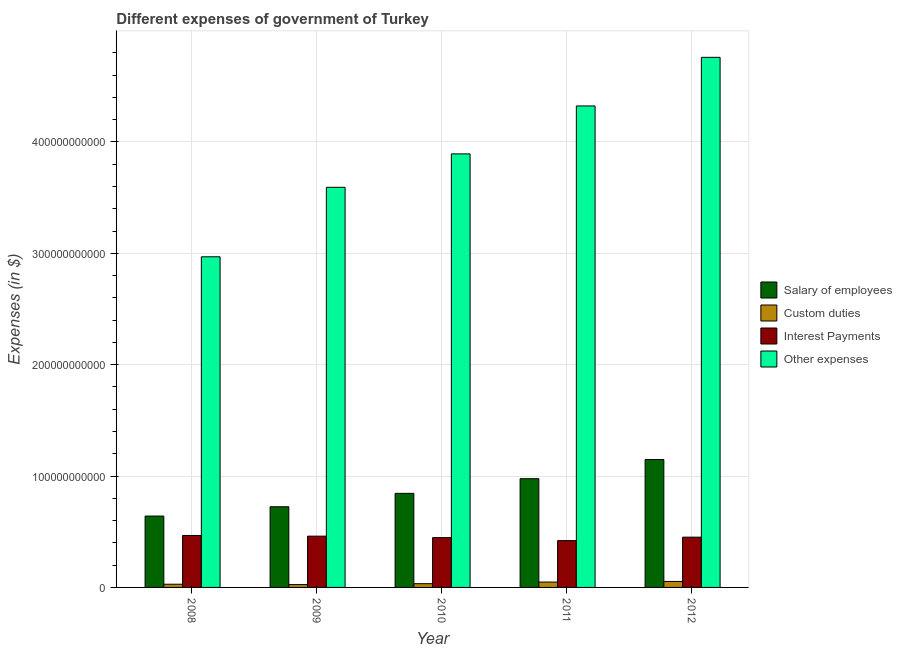How many bars are there on the 5th tick from the right?
Keep it short and to the point. 4. In how many cases, is the number of bars for a given year not equal to the number of legend labels?
Provide a succinct answer. 0. What is the amount spent on other expenses in 2011?
Offer a very short reply. 4.32e+11. Across all years, what is the maximum amount spent on custom duties?
Offer a very short reply. 5.37e+09. Across all years, what is the minimum amount spent on other expenses?
Provide a short and direct response. 2.97e+11. In which year was the amount spent on salary of employees minimum?
Give a very brief answer. 2008. What is the total amount spent on custom duties in the graph?
Give a very brief answer. 1.90e+1. What is the difference between the amount spent on custom duties in 2010 and that in 2012?
Offer a very short reply. -2.01e+09. What is the difference between the amount spent on interest payments in 2009 and the amount spent on salary of employees in 2010?
Offer a terse response. 1.33e+09. What is the average amount spent on interest payments per year?
Provide a succinct answer. 4.49e+1. In how many years, is the amount spent on salary of employees greater than 220000000000 $?
Give a very brief answer. 0. What is the ratio of the amount spent on interest payments in 2011 to that in 2012?
Make the answer very short. 0.93. Is the amount spent on interest payments in 2008 less than that in 2011?
Provide a succinct answer. No. What is the difference between the highest and the second highest amount spent on other expenses?
Ensure brevity in your answer.  4.37e+1. What is the difference between the highest and the lowest amount spent on salary of employees?
Your answer should be very brief. 5.07e+1. In how many years, is the amount spent on custom duties greater than the average amount spent on custom duties taken over all years?
Ensure brevity in your answer.  2. What does the 1st bar from the left in 2012 represents?
Offer a very short reply. Salary of employees. What does the 2nd bar from the right in 2008 represents?
Your response must be concise. Interest Payments. How many bars are there?
Your response must be concise. 20. How many years are there in the graph?
Offer a terse response. 5. What is the difference between two consecutive major ticks on the Y-axis?
Your answer should be very brief. 1.00e+11. Does the graph contain any zero values?
Provide a succinct answer. No. Where does the legend appear in the graph?
Provide a succinct answer. Center right. How many legend labels are there?
Keep it short and to the point. 4. What is the title of the graph?
Keep it short and to the point. Different expenses of government of Turkey. Does "Terrestrial protected areas" appear as one of the legend labels in the graph?
Give a very brief answer. No. What is the label or title of the X-axis?
Provide a succinct answer. Year. What is the label or title of the Y-axis?
Provide a short and direct response. Expenses (in $). What is the Expenses (in $) in Salary of employees in 2008?
Keep it short and to the point. 6.41e+1. What is the Expenses (in $) of Custom duties in 2008?
Make the answer very short. 2.87e+09. What is the Expenses (in $) of Interest Payments in 2008?
Your answer should be compact. 4.67e+1. What is the Expenses (in $) of Other expenses in 2008?
Make the answer very short. 2.97e+11. What is the Expenses (in $) of Salary of employees in 2009?
Your answer should be very brief. 7.24e+1. What is the Expenses (in $) in Custom duties in 2009?
Ensure brevity in your answer.  2.56e+09. What is the Expenses (in $) in Interest Payments in 2009?
Provide a short and direct response. 4.60e+1. What is the Expenses (in $) of Other expenses in 2009?
Offer a very short reply. 3.59e+11. What is the Expenses (in $) of Salary of employees in 2010?
Your answer should be very brief. 8.45e+1. What is the Expenses (in $) in Custom duties in 2010?
Offer a very short reply. 3.36e+09. What is the Expenses (in $) of Interest Payments in 2010?
Provide a short and direct response. 4.47e+1. What is the Expenses (in $) in Other expenses in 2010?
Make the answer very short. 3.89e+11. What is the Expenses (in $) of Salary of employees in 2011?
Keep it short and to the point. 9.76e+1. What is the Expenses (in $) in Custom duties in 2011?
Your answer should be very brief. 4.82e+09. What is the Expenses (in $) of Interest Payments in 2011?
Your answer should be very brief. 4.20e+1. What is the Expenses (in $) in Other expenses in 2011?
Keep it short and to the point. 4.32e+11. What is the Expenses (in $) of Salary of employees in 2012?
Offer a very short reply. 1.15e+11. What is the Expenses (in $) of Custom duties in 2012?
Provide a short and direct response. 5.37e+09. What is the Expenses (in $) in Interest Payments in 2012?
Your response must be concise. 4.51e+1. What is the Expenses (in $) in Other expenses in 2012?
Ensure brevity in your answer.  4.76e+11. Across all years, what is the maximum Expenses (in $) of Salary of employees?
Provide a short and direct response. 1.15e+11. Across all years, what is the maximum Expenses (in $) in Custom duties?
Keep it short and to the point. 5.37e+09. Across all years, what is the maximum Expenses (in $) of Interest Payments?
Keep it short and to the point. 4.67e+1. Across all years, what is the maximum Expenses (in $) of Other expenses?
Give a very brief answer. 4.76e+11. Across all years, what is the minimum Expenses (in $) of Salary of employees?
Offer a terse response. 6.41e+1. Across all years, what is the minimum Expenses (in $) of Custom duties?
Keep it short and to the point. 2.56e+09. Across all years, what is the minimum Expenses (in $) in Interest Payments?
Your answer should be compact. 4.20e+1. Across all years, what is the minimum Expenses (in $) in Other expenses?
Make the answer very short. 2.97e+11. What is the total Expenses (in $) in Salary of employees in the graph?
Your answer should be compact. 4.33e+11. What is the total Expenses (in $) in Custom duties in the graph?
Your answer should be compact. 1.90e+1. What is the total Expenses (in $) in Interest Payments in the graph?
Offer a terse response. 2.25e+11. What is the total Expenses (in $) of Other expenses in the graph?
Offer a very short reply. 1.95e+12. What is the difference between the Expenses (in $) in Salary of employees in 2008 and that in 2009?
Ensure brevity in your answer.  -8.34e+09. What is the difference between the Expenses (in $) in Custom duties in 2008 and that in 2009?
Ensure brevity in your answer.  3.18e+08. What is the difference between the Expenses (in $) in Interest Payments in 2008 and that in 2009?
Your answer should be compact. 6.15e+08. What is the difference between the Expenses (in $) of Other expenses in 2008 and that in 2009?
Your response must be concise. -6.24e+1. What is the difference between the Expenses (in $) in Salary of employees in 2008 and that in 2010?
Make the answer very short. -2.04e+1. What is the difference between the Expenses (in $) of Custom duties in 2008 and that in 2010?
Provide a succinct answer. -4.83e+08. What is the difference between the Expenses (in $) of Interest Payments in 2008 and that in 2010?
Offer a terse response. 1.95e+09. What is the difference between the Expenses (in $) of Other expenses in 2008 and that in 2010?
Provide a short and direct response. -9.24e+1. What is the difference between the Expenses (in $) of Salary of employees in 2008 and that in 2011?
Your answer should be very brief. -3.35e+1. What is the difference between the Expenses (in $) of Custom duties in 2008 and that in 2011?
Keep it short and to the point. -1.95e+09. What is the difference between the Expenses (in $) in Interest Payments in 2008 and that in 2011?
Keep it short and to the point. 4.62e+09. What is the difference between the Expenses (in $) of Other expenses in 2008 and that in 2011?
Make the answer very short. -1.35e+11. What is the difference between the Expenses (in $) in Salary of employees in 2008 and that in 2012?
Ensure brevity in your answer.  -5.07e+1. What is the difference between the Expenses (in $) in Custom duties in 2008 and that in 2012?
Offer a very short reply. -2.49e+09. What is the difference between the Expenses (in $) in Interest Payments in 2008 and that in 2012?
Provide a succinct answer. 1.53e+09. What is the difference between the Expenses (in $) in Other expenses in 2008 and that in 2012?
Provide a short and direct response. -1.79e+11. What is the difference between the Expenses (in $) of Salary of employees in 2009 and that in 2010?
Your answer should be very brief. -1.20e+1. What is the difference between the Expenses (in $) of Custom duties in 2009 and that in 2010?
Give a very brief answer. -8.01e+08. What is the difference between the Expenses (in $) in Interest Payments in 2009 and that in 2010?
Offer a very short reply. 1.33e+09. What is the difference between the Expenses (in $) of Other expenses in 2009 and that in 2010?
Your response must be concise. -3.00e+1. What is the difference between the Expenses (in $) in Salary of employees in 2009 and that in 2011?
Provide a short and direct response. -2.52e+1. What is the difference between the Expenses (in $) in Custom duties in 2009 and that in 2011?
Make the answer very short. -2.27e+09. What is the difference between the Expenses (in $) of Interest Payments in 2009 and that in 2011?
Provide a succinct answer. 4.01e+09. What is the difference between the Expenses (in $) of Other expenses in 2009 and that in 2011?
Your response must be concise. -7.30e+1. What is the difference between the Expenses (in $) of Salary of employees in 2009 and that in 2012?
Offer a very short reply. -4.24e+1. What is the difference between the Expenses (in $) of Custom duties in 2009 and that in 2012?
Ensure brevity in your answer.  -2.81e+09. What is the difference between the Expenses (in $) of Interest Payments in 2009 and that in 2012?
Your response must be concise. 9.15e+08. What is the difference between the Expenses (in $) in Other expenses in 2009 and that in 2012?
Keep it short and to the point. -1.17e+11. What is the difference between the Expenses (in $) in Salary of employees in 2010 and that in 2011?
Give a very brief answer. -1.32e+1. What is the difference between the Expenses (in $) in Custom duties in 2010 and that in 2011?
Offer a very short reply. -1.46e+09. What is the difference between the Expenses (in $) in Interest Payments in 2010 and that in 2011?
Your answer should be very brief. 2.68e+09. What is the difference between the Expenses (in $) in Other expenses in 2010 and that in 2011?
Give a very brief answer. -4.30e+1. What is the difference between the Expenses (in $) of Salary of employees in 2010 and that in 2012?
Give a very brief answer. -3.04e+1. What is the difference between the Expenses (in $) in Custom duties in 2010 and that in 2012?
Ensure brevity in your answer.  -2.01e+09. What is the difference between the Expenses (in $) of Interest Payments in 2010 and that in 2012?
Your answer should be very brief. -4.16e+08. What is the difference between the Expenses (in $) of Other expenses in 2010 and that in 2012?
Make the answer very short. -8.67e+1. What is the difference between the Expenses (in $) of Salary of employees in 2011 and that in 2012?
Ensure brevity in your answer.  -1.72e+1. What is the difference between the Expenses (in $) of Custom duties in 2011 and that in 2012?
Offer a terse response. -5.47e+08. What is the difference between the Expenses (in $) in Interest Payments in 2011 and that in 2012?
Give a very brief answer. -3.09e+09. What is the difference between the Expenses (in $) in Other expenses in 2011 and that in 2012?
Your response must be concise. -4.37e+1. What is the difference between the Expenses (in $) in Salary of employees in 2008 and the Expenses (in $) in Custom duties in 2009?
Keep it short and to the point. 6.15e+1. What is the difference between the Expenses (in $) of Salary of employees in 2008 and the Expenses (in $) of Interest Payments in 2009?
Make the answer very short. 1.80e+1. What is the difference between the Expenses (in $) in Salary of employees in 2008 and the Expenses (in $) in Other expenses in 2009?
Keep it short and to the point. -2.95e+11. What is the difference between the Expenses (in $) of Custom duties in 2008 and the Expenses (in $) of Interest Payments in 2009?
Make the answer very short. -4.32e+1. What is the difference between the Expenses (in $) of Custom duties in 2008 and the Expenses (in $) of Other expenses in 2009?
Ensure brevity in your answer.  -3.56e+11. What is the difference between the Expenses (in $) in Interest Payments in 2008 and the Expenses (in $) in Other expenses in 2009?
Make the answer very short. -3.13e+11. What is the difference between the Expenses (in $) in Salary of employees in 2008 and the Expenses (in $) in Custom duties in 2010?
Your response must be concise. 6.07e+1. What is the difference between the Expenses (in $) of Salary of employees in 2008 and the Expenses (in $) of Interest Payments in 2010?
Keep it short and to the point. 1.94e+1. What is the difference between the Expenses (in $) in Salary of employees in 2008 and the Expenses (in $) in Other expenses in 2010?
Give a very brief answer. -3.25e+11. What is the difference between the Expenses (in $) in Custom duties in 2008 and the Expenses (in $) in Interest Payments in 2010?
Ensure brevity in your answer.  -4.18e+1. What is the difference between the Expenses (in $) of Custom duties in 2008 and the Expenses (in $) of Other expenses in 2010?
Provide a short and direct response. -3.86e+11. What is the difference between the Expenses (in $) of Interest Payments in 2008 and the Expenses (in $) of Other expenses in 2010?
Keep it short and to the point. -3.43e+11. What is the difference between the Expenses (in $) of Salary of employees in 2008 and the Expenses (in $) of Custom duties in 2011?
Give a very brief answer. 5.93e+1. What is the difference between the Expenses (in $) of Salary of employees in 2008 and the Expenses (in $) of Interest Payments in 2011?
Ensure brevity in your answer.  2.21e+1. What is the difference between the Expenses (in $) of Salary of employees in 2008 and the Expenses (in $) of Other expenses in 2011?
Your answer should be very brief. -3.68e+11. What is the difference between the Expenses (in $) of Custom duties in 2008 and the Expenses (in $) of Interest Payments in 2011?
Keep it short and to the point. -3.92e+1. What is the difference between the Expenses (in $) in Custom duties in 2008 and the Expenses (in $) in Other expenses in 2011?
Provide a succinct answer. -4.29e+11. What is the difference between the Expenses (in $) in Interest Payments in 2008 and the Expenses (in $) in Other expenses in 2011?
Your answer should be very brief. -3.86e+11. What is the difference between the Expenses (in $) in Salary of employees in 2008 and the Expenses (in $) in Custom duties in 2012?
Provide a succinct answer. 5.87e+1. What is the difference between the Expenses (in $) of Salary of employees in 2008 and the Expenses (in $) of Interest Payments in 2012?
Provide a short and direct response. 1.90e+1. What is the difference between the Expenses (in $) in Salary of employees in 2008 and the Expenses (in $) in Other expenses in 2012?
Offer a terse response. -4.12e+11. What is the difference between the Expenses (in $) of Custom duties in 2008 and the Expenses (in $) of Interest Payments in 2012?
Offer a very short reply. -4.22e+1. What is the difference between the Expenses (in $) of Custom duties in 2008 and the Expenses (in $) of Other expenses in 2012?
Offer a terse response. -4.73e+11. What is the difference between the Expenses (in $) in Interest Payments in 2008 and the Expenses (in $) in Other expenses in 2012?
Give a very brief answer. -4.29e+11. What is the difference between the Expenses (in $) of Salary of employees in 2009 and the Expenses (in $) of Custom duties in 2010?
Ensure brevity in your answer.  6.91e+1. What is the difference between the Expenses (in $) in Salary of employees in 2009 and the Expenses (in $) in Interest Payments in 2010?
Provide a short and direct response. 2.77e+1. What is the difference between the Expenses (in $) of Salary of employees in 2009 and the Expenses (in $) of Other expenses in 2010?
Ensure brevity in your answer.  -3.17e+11. What is the difference between the Expenses (in $) in Custom duties in 2009 and the Expenses (in $) in Interest Payments in 2010?
Provide a short and direct response. -4.21e+1. What is the difference between the Expenses (in $) of Custom duties in 2009 and the Expenses (in $) of Other expenses in 2010?
Provide a short and direct response. -3.87e+11. What is the difference between the Expenses (in $) of Interest Payments in 2009 and the Expenses (in $) of Other expenses in 2010?
Your answer should be very brief. -3.43e+11. What is the difference between the Expenses (in $) of Salary of employees in 2009 and the Expenses (in $) of Custom duties in 2011?
Provide a succinct answer. 6.76e+1. What is the difference between the Expenses (in $) in Salary of employees in 2009 and the Expenses (in $) in Interest Payments in 2011?
Your answer should be very brief. 3.04e+1. What is the difference between the Expenses (in $) of Salary of employees in 2009 and the Expenses (in $) of Other expenses in 2011?
Keep it short and to the point. -3.60e+11. What is the difference between the Expenses (in $) in Custom duties in 2009 and the Expenses (in $) in Interest Payments in 2011?
Make the answer very short. -3.95e+1. What is the difference between the Expenses (in $) of Custom duties in 2009 and the Expenses (in $) of Other expenses in 2011?
Provide a short and direct response. -4.30e+11. What is the difference between the Expenses (in $) of Interest Payments in 2009 and the Expenses (in $) of Other expenses in 2011?
Provide a short and direct response. -3.86e+11. What is the difference between the Expenses (in $) of Salary of employees in 2009 and the Expenses (in $) of Custom duties in 2012?
Your response must be concise. 6.71e+1. What is the difference between the Expenses (in $) in Salary of employees in 2009 and the Expenses (in $) in Interest Payments in 2012?
Make the answer very short. 2.73e+1. What is the difference between the Expenses (in $) in Salary of employees in 2009 and the Expenses (in $) in Other expenses in 2012?
Ensure brevity in your answer.  -4.04e+11. What is the difference between the Expenses (in $) of Custom duties in 2009 and the Expenses (in $) of Interest Payments in 2012?
Your response must be concise. -4.26e+1. What is the difference between the Expenses (in $) in Custom duties in 2009 and the Expenses (in $) in Other expenses in 2012?
Make the answer very short. -4.73e+11. What is the difference between the Expenses (in $) of Interest Payments in 2009 and the Expenses (in $) of Other expenses in 2012?
Ensure brevity in your answer.  -4.30e+11. What is the difference between the Expenses (in $) in Salary of employees in 2010 and the Expenses (in $) in Custom duties in 2011?
Your response must be concise. 7.96e+1. What is the difference between the Expenses (in $) in Salary of employees in 2010 and the Expenses (in $) in Interest Payments in 2011?
Provide a succinct answer. 4.24e+1. What is the difference between the Expenses (in $) in Salary of employees in 2010 and the Expenses (in $) in Other expenses in 2011?
Give a very brief answer. -3.48e+11. What is the difference between the Expenses (in $) in Custom duties in 2010 and the Expenses (in $) in Interest Payments in 2011?
Your answer should be very brief. -3.87e+1. What is the difference between the Expenses (in $) in Custom duties in 2010 and the Expenses (in $) in Other expenses in 2011?
Your answer should be very brief. -4.29e+11. What is the difference between the Expenses (in $) in Interest Payments in 2010 and the Expenses (in $) in Other expenses in 2011?
Your answer should be very brief. -3.88e+11. What is the difference between the Expenses (in $) in Salary of employees in 2010 and the Expenses (in $) in Custom duties in 2012?
Your answer should be very brief. 7.91e+1. What is the difference between the Expenses (in $) in Salary of employees in 2010 and the Expenses (in $) in Interest Payments in 2012?
Keep it short and to the point. 3.93e+1. What is the difference between the Expenses (in $) in Salary of employees in 2010 and the Expenses (in $) in Other expenses in 2012?
Ensure brevity in your answer.  -3.91e+11. What is the difference between the Expenses (in $) in Custom duties in 2010 and the Expenses (in $) in Interest Payments in 2012?
Your answer should be very brief. -4.18e+1. What is the difference between the Expenses (in $) in Custom duties in 2010 and the Expenses (in $) in Other expenses in 2012?
Ensure brevity in your answer.  -4.73e+11. What is the difference between the Expenses (in $) of Interest Payments in 2010 and the Expenses (in $) of Other expenses in 2012?
Ensure brevity in your answer.  -4.31e+11. What is the difference between the Expenses (in $) in Salary of employees in 2011 and the Expenses (in $) in Custom duties in 2012?
Offer a terse response. 9.23e+1. What is the difference between the Expenses (in $) of Salary of employees in 2011 and the Expenses (in $) of Interest Payments in 2012?
Offer a terse response. 5.25e+1. What is the difference between the Expenses (in $) of Salary of employees in 2011 and the Expenses (in $) of Other expenses in 2012?
Ensure brevity in your answer.  -3.78e+11. What is the difference between the Expenses (in $) in Custom duties in 2011 and the Expenses (in $) in Interest Payments in 2012?
Give a very brief answer. -4.03e+1. What is the difference between the Expenses (in $) of Custom duties in 2011 and the Expenses (in $) of Other expenses in 2012?
Make the answer very short. -4.71e+11. What is the difference between the Expenses (in $) in Interest Payments in 2011 and the Expenses (in $) in Other expenses in 2012?
Offer a terse response. -4.34e+11. What is the average Expenses (in $) of Salary of employees per year?
Keep it short and to the point. 8.67e+1. What is the average Expenses (in $) in Custom duties per year?
Your answer should be compact. 3.79e+09. What is the average Expenses (in $) of Interest Payments per year?
Make the answer very short. 4.49e+1. What is the average Expenses (in $) of Other expenses per year?
Provide a short and direct response. 3.91e+11. In the year 2008, what is the difference between the Expenses (in $) in Salary of employees and Expenses (in $) in Custom duties?
Offer a terse response. 6.12e+1. In the year 2008, what is the difference between the Expenses (in $) in Salary of employees and Expenses (in $) in Interest Payments?
Ensure brevity in your answer.  1.74e+1. In the year 2008, what is the difference between the Expenses (in $) in Salary of employees and Expenses (in $) in Other expenses?
Make the answer very short. -2.33e+11. In the year 2008, what is the difference between the Expenses (in $) of Custom duties and Expenses (in $) of Interest Payments?
Give a very brief answer. -4.38e+1. In the year 2008, what is the difference between the Expenses (in $) in Custom duties and Expenses (in $) in Other expenses?
Offer a terse response. -2.94e+11. In the year 2008, what is the difference between the Expenses (in $) in Interest Payments and Expenses (in $) in Other expenses?
Keep it short and to the point. -2.50e+11. In the year 2009, what is the difference between the Expenses (in $) of Salary of employees and Expenses (in $) of Custom duties?
Offer a very short reply. 6.99e+1. In the year 2009, what is the difference between the Expenses (in $) in Salary of employees and Expenses (in $) in Interest Payments?
Make the answer very short. 2.64e+1. In the year 2009, what is the difference between the Expenses (in $) in Salary of employees and Expenses (in $) in Other expenses?
Offer a terse response. -2.87e+11. In the year 2009, what is the difference between the Expenses (in $) of Custom duties and Expenses (in $) of Interest Payments?
Give a very brief answer. -4.35e+1. In the year 2009, what is the difference between the Expenses (in $) in Custom duties and Expenses (in $) in Other expenses?
Give a very brief answer. -3.57e+11. In the year 2009, what is the difference between the Expenses (in $) in Interest Payments and Expenses (in $) in Other expenses?
Offer a terse response. -3.13e+11. In the year 2010, what is the difference between the Expenses (in $) in Salary of employees and Expenses (in $) in Custom duties?
Provide a short and direct response. 8.11e+1. In the year 2010, what is the difference between the Expenses (in $) of Salary of employees and Expenses (in $) of Interest Payments?
Your response must be concise. 3.98e+1. In the year 2010, what is the difference between the Expenses (in $) in Salary of employees and Expenses (in $) in Other expenses?
Your response must be concise. -3.05e+11. In the year 2010, what is the difference between the Expenses (in $) in Custom duties and Expenses (in $) in Interest Payments?
Make the answer very short. -4.13e+1. In the year 2010, what is the difference between the Expenses (in $) of Custom duties and Expenses (in $) of Other expenses?
Offer a very short reply. -3.86e+11. In the year 2010, what is the difference between the Expenses (in $) of Interest Payments and Expenses (in $) of Other expenses?
Provide a succinct answer. -3.45e+11. In the year 2011, what is the difference between the Expenses (in $) in Salary of employees and Expenses (in $) in Custom duties?
Give a very brief answer. 9.28e+1. In the year 2011, what is the difference between the Expenses (in $) of Salary of employees and Expenses (in $) of Interest Payments?
Offer a very short reply. 5.56e+1. In the year 2011, what is the difference between the Expenses (in $) of Salary of employees and Expenses (in $) of Other expenses?
Make the answer very short. -3.35e+11. In the year 2011, what is the difference between the Expenses (in $) of Custom duties and Expenses (in $) of Interest Payments?
Keep it short and to the point. -3.72e+1. In the year 2011, what is the difference between the Expenses (in $) of Custom duties and Expenses (in $) of Other expenses?
Give a very brief answer. -4.27e+11. In the year 2011, what is the difference between the Expenses (in $) in Interest Payments and Expenses (in $) in Other expenses?
Give a very brief answer. -3.90e+11. In the year 2012, what is the difference between the Expenses (in $) in Salary of employees and Expenses (in $) in Custom duties?
Your answer should be very brief. 1.09e+11. In the year 2012, what is the difference between the Expenses (in $) of Salary of employees and Expenses (in $) of Interest Payments?
Your response must be concise. 6.97e+1. In the year 2012, what is the difference between the Expenses (in $) of Salary of employees and Expenses (in $) of Other expenses?
Offer a very short reply. -3.61e+11. In the year 2012, what is the difference between the Expenses (in $) in Custom duties and Expenses (in $) in Interest Payments?
Provide a short and direct response. -3.98e+1. In the year 2012, what is the difference between the Expenses (in $) of Custom duties and Expenses (in $) of Other expenses?
Make the answer very short. -4.71e+11. In the year 2012, what is the difference between the Expenses (in $) of Interest Payments and Expenses (in $) of Other expenses?
Give a very brief answer. -4.31e+11. What is the ratio of the Expenses (in $) of Salary of employees in 2008 to that in 2009?
Ensure brevity in your answer.  0.88. What is the ratio of the Expenses (in $) in Custom duties in 2008 to that in 2009?
Your response must be concise. 1.12. What is the ratio of the Expenses (in $) of Interest Payments in 2008 to that in 2009?
Offer a terse response. 1.01. What is the ratio of the Expenses (in $) of Other expenses in 2008 to that in 2009?
Your response must be concise. 0.83. What is the ratio of the Expenses (in $) of Salary of employees in 2008 to that in 2010?
Make the answer very short. 0.76. What is the ratio of the Expenses (in $) of Custom duties in 2008 to that in 2010?
Provide a short and direct response. 0.86. What is the ratio of the Expenses (in $) in Interest Payments in 2008 to that in 2010?
Ensure brevity in your answer.  1.04. What is the ratio of the Expenses (in $) in Other expenses in 2008 to that in 2010?
Make the answer very short. 0.76. What is the ratio of the Expenses (in $) of Salary of employees in 2008 to that in 2011?
Ensure brevity in your answer.  0.66. What is the ratio of the Expenses (in $) in Custom duties in 2008 to that in 2011?
Make the answer very short. 0.6. What is the ratio of the Expenses (in $) of Interest Payments in 2008 to that in 2011?
Your answer should be compact. 1.11. What is the ratio of the Expenses (in $) in Other expenses in 2008 to that in 2011?
Give a very brief answer. 0.69. What is the ratio of the Expenses (in $) of Salary of employees in 2008 to that in 2012?
Provide a short and direct response. 0.56. What is the ratio of the Expenses (in $) of Custom duties in 2008 to that in 2012?
Your answer should be very brief. 0.54. What is the ratio of the Expenses (in $) in Interest Payments in 2008 to that in 2012?
Offer a very short reply. 1.03. What is the ratio of the Expenses (in $) in Other expenses in 2008 to that in 2012?
Offer a very short reply. 0.62. What is the ratio of the Expenses (in $) in Salary of employees in 2009 to that in 2010?
Ensure brevity in your answer.  0.86. What is the ratio of the Expenses (in $) in Custom duties in 2009 to that in 2010?
Provide a succinct answer. 0.76. What is the ratio of the Expenses (in $) in Interest Payments in 2009 to that in 2010?
Your response must be concise. 1.03. What is the ratio of the Expenses (in $) of Other expenses in 2009 to that in 2010?
Your answer should be compact. 0.92. What is the ratio of the Expenses (in $) of Salary of employees in 2009 to that in 2011?
Your answer should be very brief. 0.74. What is the ratio of the Expenses (in $) of Custom duties in 2009 to that in 2011?
Keep it short and to the point. 0.53. What is the ratio of the Expenses (in $) in Interest Payments in 2009 to that in 2011?
Offer a terse response. 1.1. What is the ratio of the Expenses (in $) of Other expenses in 2009 to that in 2011?
Provide a short and direct response. 0.83. What is the ratio of the Expenses (in $) in Salary of employees in 2009 to that in 2012?
Make the answer very short. 0.63. What is the ratio of the Expenses (in $) in Custom duties in 2009 to that in 2012?
Provide a succinct answer. 0.48. What is the ratio of the Expenses (in $) in Interest Payments in 2009 to that in 2012?
Offer a very short reply. 1.02. What is the ratio of the Expenses (in $) of Other expenses in 2009 to that in 2012?
Keep it short and to the point. 0.75. What is the ratio of the Expenses (in $) in Salary of employees in 2010 to that in 2011?
Ensure brevity in your answer.  0.87. What is the ratio of the Expenses (in $) in Custom duties in 2010 to that in 2011?
Give a very brief answer. 0.7. What is the ratio of the Expenses (in $) of Interest Payments in 2010 to that in 2011?
Your response must be concise. 1.06. What is the ratio of the Expenses (in $) in Other expenses in 2010 to that in 2011?
Keep it short and to the point. 0.9. What is the ratio of the Expenses (in $) in Salary of employees in 2010 to that in 2012?
Offer a terse response. 0.74. What is the ratio of the Expenses (in $) in Custom duties in 2010 to that in 2012?
Provide a short and direct response. 0.63. What is the ratio of the Expenses (in $) of Interest Payments in 2010 to that in 2012?
Your answer should be compact. 0.99. What is the ratio of the Expenses (in $) of Other expenses in 2010 to that in 2012?
Offer a terse response. 0.82. What is the ratio of the Expenses (in $) in Salary of employees in 2011 to that in 2012?
Your answer should be compact. 0.85. What is the ratio of the Expenses (in $) in Custom duties in 2011 to that in 2012?
Provide a short and direct response. 0.9. What is the ratio of the Expenses (in $) in Interest Payments in 2011 to that in 2012?
Offer a very short reply. 0.93. What is the ratio of the Expenses (in $) of Other expenses in 2011 to that in 2012?
Ensure brevity in your answer.  0.91. What is the difference between the highest and the second highest Expenses (in $) in Salary of employees?
Ensure brevity in your answer.  1.72e+1. What is the difference between the highest and the second highest Expenses (in $) in Custom duties?
Your response must be concise. 5.47e+08. What is the difference between the highest and the second highest Expenses (in $) in Interest Payments?
Your answer should be very brief. 6.15e+08. What is the difference between the highest and the second highest Expenses (in $) of Other expenses?
Give a very brief answer. 4.37e+1. What is the difference between the highest and the lowest Expenses (in $) in Salary of employees?
Provide a short and direct response. 5.07e+1. What is the difference between the highest and the lowest Expenses (in $) of Custom duties?
Your answer should be very brief. 2.81e+09. What is the difference between the highest and the lowest Expenses (in $) of Interest Payments?
Provide a short and direct response. 4.62e+09. What is the difference between the highest and the lowest Expenses (in $) in Other expenses?
Make the answer very short. 1.79e+11. 